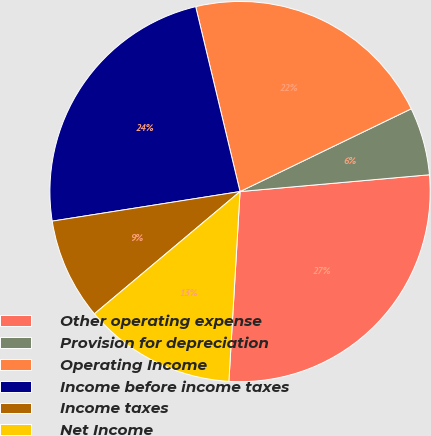Convert chart. <chart><loc_0><loc_0><loc_500><loc_500><pie_chart><fcel>Other operating expense<fcel>Provision for depreciation<fcel>Operating Income<fcel>Income before income taxes<fcel>Income taxes<fcel>Net Income<nl><fcel>27.34%<fcel>5.76%<fcel>21.58%<fcel>23.74%<fcel>8.63%<fcel>12.95%<nl></chart> 